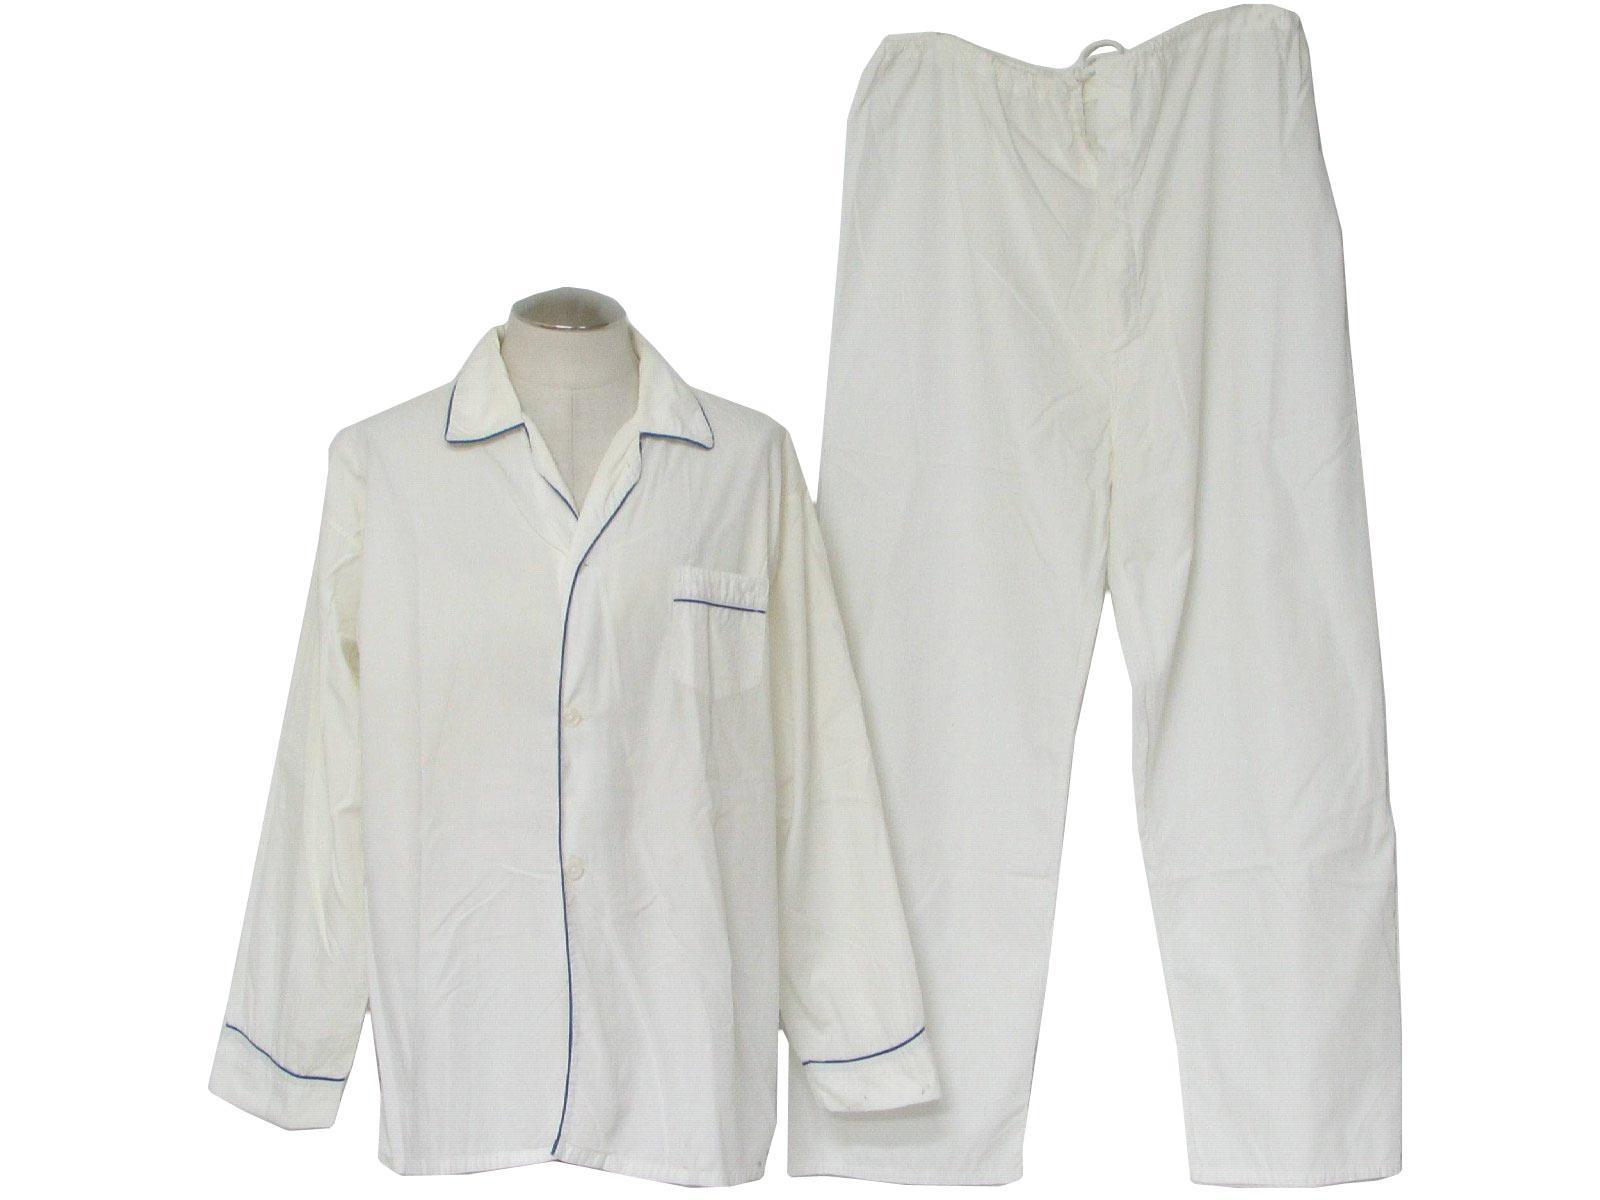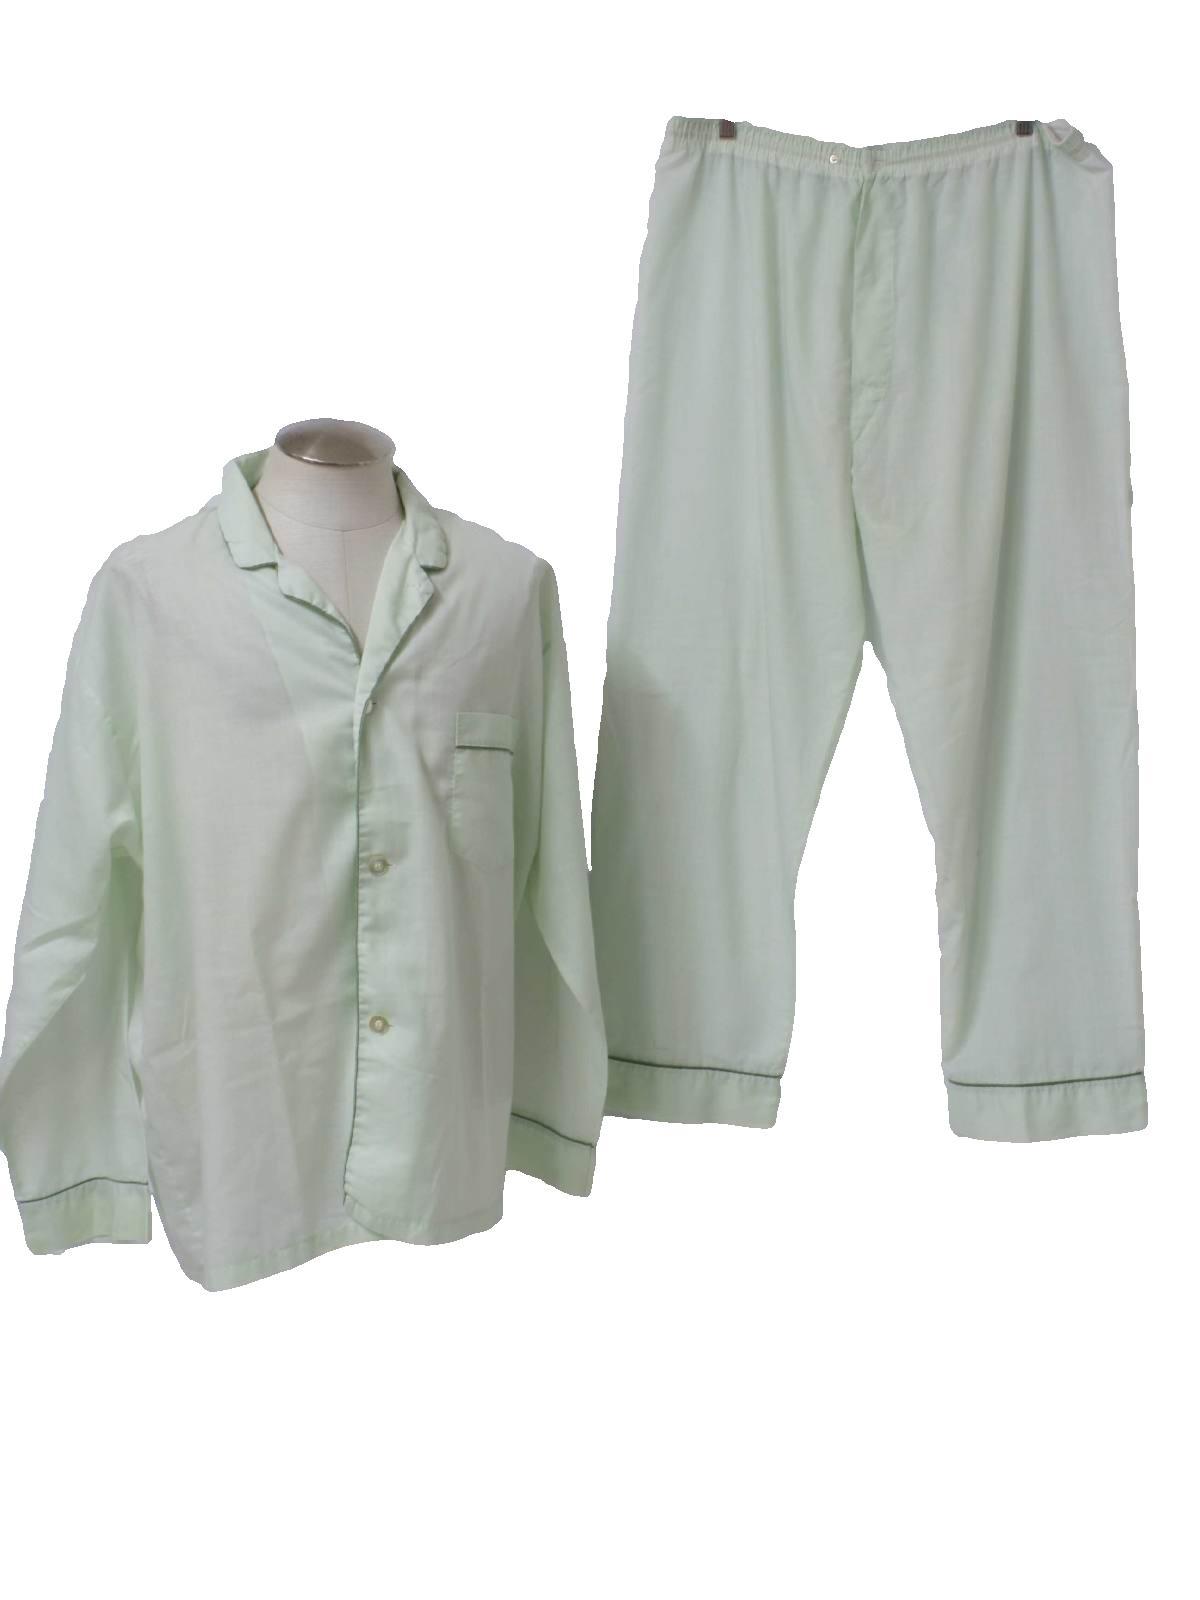The first image is the image on the left, the second image is the image on the right. Examine the images to the left and right. Is the description "there is a short sleeved two piece pajama with a callar and front pockets" accurate? Answer yes or no. No. 